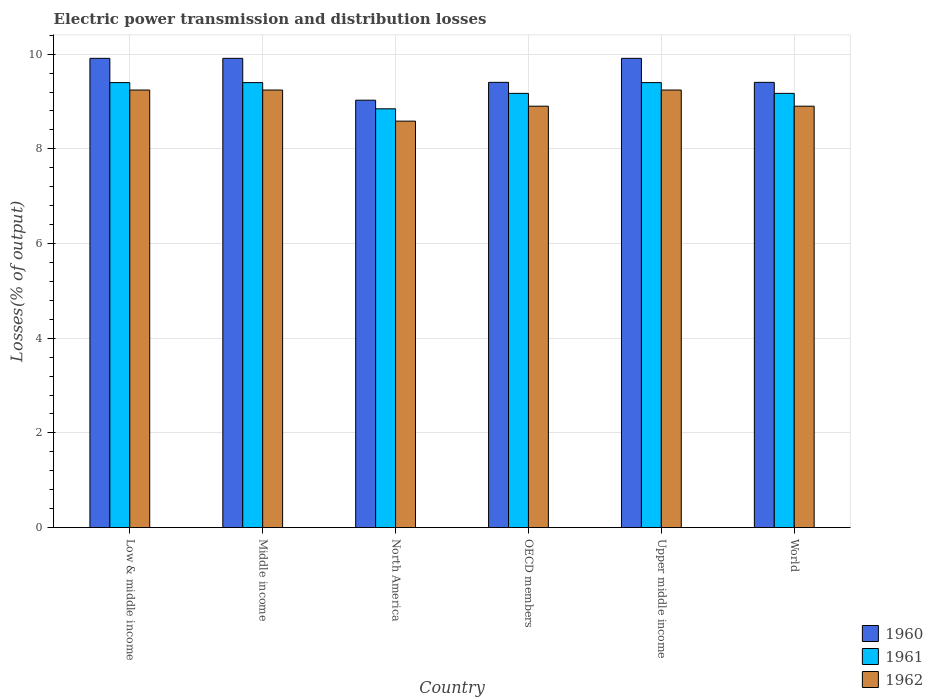How many different coloured bars are there?
Make the answer very short. 3. Are the number of bars per tick equal to the number of legend labels?
Your answer should be very brief. Yes. Are the number of bars on each tick of the X-axis equal?
Your answer should be compact. Yes. How many bars are there on the 6th tick from the right?
Provide a short and direct response. 3. What is the label of the 5th group of bars from the left?
Your answer should be very brief. Upper middle income. In how many cases, is the number of bars for a given country not equal to the number of legend labels?
Your response must be concise. 0. What is the electric power transmission and distribution losses in 1962 in World?
Give a very brief answer. 8.9. Across all countries, what is the maximum electric power transmission and distribution losses in 1961?
Provide a succinct answer. 9.4. Across all countries, what is the minimum electric power transmission and distribution losses in 1962?
Give a very brief answer. 8.59. In which country was the electric power transmission and distribution losses in 1961 maximum?
Offer a very short reply. Low & middle income. In which country was the electric power transmission and distribution losses in 1961 minimum?
Make the answer very short. North America. What is the total electric power transmission and distribution losses in 1961 in the graph?
Ensure brevity in your answer.  55.38. What is the difference between the electric power transmission and distribution losses in 1961 in Low & middle income and that in North America?
Offer a very short reply. 0.55. What is the difference between the electric power transmission and distribution losses in 1962 in Low & middle income and the electric power transmission and distribution losses in 1960 in Middle income?
Keep it short and to the point. -0.67. What is the average electric power transmission and distribution losses in 1960 per country?
Give a very brief answer. 9.59. What is the difference between the electric power transmission and distribution losses of/in 1960 and electric power transmission and distribution losses of/in 1961 in Upper middle income?
Your response must be concise. 0.51. In how many countries, is the electric power transmission and distribution losses in 1961 greater than 8.8 %?
Provide a short and direct response. 6. Is the difference between the electric power transmission and distribution losses in 1960 in Low & middle income and North America greater than the difference between the electric power transmission and distribution losses in 1961 in Low & middle income and North America?
Offer a terse response. Yes. What is the difference between the highest and the lowest electric power transmission and distribution losses in 1961?
Provide a succinct answer. 0.55. In how many countries, is the electric power transmission and distribution losses in 1960 greater than the average electric power transmission and distribution losses in 1960 taken over all countries?
Give a very brief answer. 3. Is the sum of the electric power transmission and distribution losses in 1961 in OECD members and World greater than the maximum electric power transmission and distribution losses in 1960 across all countries?
Keep it short and to the point. Yes. What does the 2nd bar from the right in Upper middle income represents?
Make the answer very short. 1961. Is it the case that in every country, the sum of the electric power transmission and distribution losses in 1961 and electric power transmission and distribution losses in 1962 is greater than the electric power transmission and distribution losses in 1960?
Ensure brevity in your answer.  Yes. How many bars are there?
Provide a short and direct response. 18. How are the legend labels stacked?
Your response must be concise. Vertical. What is the title of the graph?
Offer a very short reply. Electric power transmission and distribution losses. Does "2007" appear as one of the legend labels in the graph?
Give a very brief answer. No. What is the label or title of the X-axis?
Ensure brevity in your answer.  Country. What is the label or title of the Y-axis?
Make the answer very short. Losses(% of output). What is the Losses(% of output) in 1960 in Low & middle income?
Your answer should be very brief. 9.91. What is the Losses(% of output) of 1961 in Low & middle income?
Your answer should be compact. 9.4. What is the Losses(% of output) of 1962 in Low & middle income?
Keep it short and to the point. 9.24. What is the Losses(% of output) in 1960 in Middle income?
Offer a terse response. 9.91. What is the Losses(% of output) of 1961 in Middle income?
Your response must be concise. 9.4. What is the Losses(% of output) of 1962 in Middle income?
Offer a very short reply. 9.24. What is the Losses(% of output) of 1960 in North America?
Provide a short and direct response. 9.03. What is the Losses(% of output) in 1961 in North America?
Give a very brief answer. 8.85. What is the Losses(% of output) in 1962 in North America?
Give a very brief answer. 8.59. What is the Losses(% of output) in 1960 in OECD members?
Provide a short and direct response. 9.4. What is the Losses(% of output) of 1961 in OECD members?
Provide a short and direct response. 9.17. What is the Losses(% of output) in 1962 in OECD members?
Provide a short and direct response. 8.9. What is the Losses(% of output) in 1960 in Upper middle income?
Provide a succinct answer. 9.91. What is the Losses(% of output) of 1961 in Upper middle income?
Offer a very short reply. 9.4. What is the Losses(% of output) of 1962 in Upper middle income?
Your answer should be very brief. 9.24. What is the Losses(% of output) in 1960 in World?
Ensure brevity in your answer.  9.4. What is the Losses(% of output) in 1961 in World?
Keep it short and to the point. 9.17. What is the Losses(% of output) in 1962 in World?
Keep it short and to the point. 8.9. Across all countries, what is the maximum Losses(% of output) of 1960?
Offer a very short reply. 9.91. Across all countries, what is the maximum Losses(% of output) in 1961?
Offer a very short reply. 9.4. Across all countries, what is the maximum Losses(% of output) in 1962?
Offer a very short reply. 9.24. Across all countries, what is the minimum Losses(% of output) in 1960?
Your response must be concise. 9.03. Across all countries, what is the minimum Losses(% of output) of 1961?
Your answer should be very brief. 8.85. Across all countries, what is the minimum Losses(% of output) of 1962?
Give a very brief answer. 8.59. What is the total Losses(% of output) in 1960 in the graph?
Your response must be concise. 57.57. What is the total Losses(% of output) in 1961 in the graph?
Make the answer very short. 55.38. What is the total Losses(% of output) in 1962 in the graph?
Offer a very short reply. 54.11. What is the difference between the Losses(% of output) of 1962 in Low & middle income and that in Middle income?
Give a very brief answer. 0. What is the difference between the Losses(% of output) in 1960 in Low & middle income and that in North America?
Your answer should be very brief. 0.88. What is the difference between the Losses(% of output) in 1961 in Low & middle income and that in North America?
Offer a very short reply. 0.55. What is the difference between the Losses(% of output) in 1962 in Low & middle income and that in North America?
Ensure brevity in your answer.  0.66. What is the difference between the Losses(% of output) of 1960 in Low & middle income and that in OECD members?
Provide a succinct answer. 0.51. What is the difference between the Losses(% of output) in 1961 in Low & middle income and that in OECD members?
Your answer should be compact. 0.23. What is the difference between the Losses(% of output) of 1962 in Low & middle income and that in OECD members?
Offer a terse response. 0.34. What is the difference between the Losses(% of output) in 1960 in Low & middle income and that in Upper middle income?
Make the answer very short. 0. What is the difference between the Losses(% of output) in 1961 in Low & middle income and that in Upper middle income?
Ensure brevity in your answer.  0. What is the difference between the Losses(% of output) of 1960 in Low & middle income and that in World?
Give a very brief answer. 0.51. What is the difference between the Losses(% of output) of 1961 in Low & middle income and that in World?
Give a very brief answer. 0.23. What is the difference between the Losses(% of output) of 1962 in Low & middle income and that in World?
Provide a short and direct response. 0.34. What is the difference between the Losses(% of output) of 1960 in Middle income and that in North America?
Your answer should be compact. 0.88. What is the difference between the Losses(% of output) in 1961 in Middle income and that in North America?
Provide a short and direct response. 0.55. What is the difference between the Losses(% of output) in 1962 in Middle income and that in North America?
Make the answer very short. 0.66. What is the difference between the Losses(% of output) of 1960 in Middle income and that in OECD members?
Your answer should be very brief. 0.51. What is the difference between the Losses(% of output) in 1961 in Middle income and that in OECD members?
Your answer should be compact. 0.23. What is the difference between the Losses(% of output) of 1962 in Middle income and that in OECD members?
Ensure brevity in your answer.  0.34. What is the difference between the Losses(% of output) in 1960 in Middle income and that in Upper middle income?
Offer a terse response. 0. What is the difference between the Losses(% of output) in 1960 in Middle income and that in World?
Your response must be concise. 0.51. What is the difference between the Losses(% of output) in 1961 in Middle income and that in World?
Make the answer very short. 0.23. What is the difference between the Losses(% of output) in 1962 in Middle income and that in World?
Keep it short and to the point. 0.34. What is the difference between the Losses(% of output) in 1960 in North America and that in OECD members?
Ensure brevity in your answer.  -0.38. What is the difference between the Losses(% of output) of 1961 in North America and that in OECD members?
Provide a short and direct response. -0.33. What is the difference between the Losses(% of output) in 1962 in North America and that in OECD members?
Keep it short and to the point. -0.32. What is the difference between the Losses(% of output) in 1960 in North America and that in Upper middle income?
Offer a terse response. -0.88. What is the difference between the Losses(% of output) in 1961 in North America and that in Upper middle income?
Your response must be concise. -0.55. What is the difference between the Losses(% of output) in 1962 in North America and that in Upper middle income?
Offer a very short reply. -0.66. What is the difference between the Losses(% of output) of 1960 in North America and that in World?
Provide a short and direct response. -0.38. What is the difference between the Losses(% of output) in 1961 in North America and that in World?
Offer a terse response. -0.33. What is the difference between the Losses(% of output) of 1962 in North America and that in World?
Ensure brevity in your answer.  -0.32. What is the difference between the Losses(% of output) of 1960 in OECD members and that in Upper middle income?
Ensure brevity in your answer.  -0.51. What is the difference between the Losses(% of output) in 1961 in OECD members and that in Upper middle income?
Make the answer very short. -0.23. What is the difference between the Losses(% of output) in 1962 in OECD members and that in Upper middle income?
Ensure brevity in your answer.  -0.34. What is the difference between the Losses(% of output) in 1961 in OECD members and that in World?
Your answer should be compact. 0. What is the difference between the Losses(% of output) of 1962 in OECD members and that in World?
Provide a succinct answer. 0. What is the difference between the Losses(% of output) of 1960 in Upper middle income and that in World?
Make the answer very short. 0.51. What is the difference between the Losses(% of output) of 1961 in Upper middle income and that in World?
Ensure brevity in your answer.  0.23. What is the difference between the Losses(% of output) of 1962 in Upper middle income and that in World?
Your response must be concise. 0.34. What is the difference between the Losses(% of output) of 1960 in Low & middle income and the Losses(% of output) of 1961 in Middle income?
Make the answer very short. 0.51. What is the difference between the Losses(% of output) in 1960 in Low & middle income and the Losses(% of output) in 1962 in Middle income?
Offer a very short reply. 0.67. What is the difference between the Losses(% of output) of 1961 in Low & middle income and the Losses(% of output) of 1962 in Middle income?
Make the answer very short. 0.16. What is the difference between the Losses(% of output) of 1960 in Low & middle income and the Losses(% of output) of 1961 in North America?
Provide a succinct answer. 1.07. What is the difference between the Losses(% of output) in 1960 in Low & middle income and the Losses(% of output) in 1962 in North America?
Provide a short and direct response. 1.33. What is the difference between the Losses(% of output) in 1961 in Low & middle income and the Losses(% of output) in 1962 in North America?
Provide a short and direct response. 0.81. What is the difference between the Losses(% of output) of 1960 in Low & middle income and the Losses(% of output) of 1961 in OECD members?
Make the answer very short. 0.74. What is the difference between the Losses(% of output) in 1960 in Low & middle income and the Losses(% of output) in 1962 in OECD members?
Ensure brevity in your answer.  1.01. What is the difference between the Losses(% of output) of 1961 in Low & middle income and the Losses(% of output) of 1962 in OECD members?
Ensure brevity in your answer.  0.5. What is the difference between the Losses(% of output) of 1960 in Low & middle income and the Losses(% of output) of 1961 in Upper middle income?
Your response must be concise. 0.51. What is the difference between the Losses(% of output) of 1960 in Low & middle income and the Losses(% of output) of 1962 in Upper middle income?
Provide a short and direct response. 0.67. What is the difference between the Losses(% of output) in 1961 in Low & middle income and the Losses(% of output) in 1962 in Upper middle income?
Provide a short and direct response. 0.16. What is the difference between the Losses(% of output) of 1960 in Low & middle income and the Losses(% of output) of 1961 in World?
Your response must be concise. 0.74. What is the difference between the Losses(% of output) of 1960 in Low & middle income and the Losses(% of output) of 1962 in World?
Your answer should be compact. 1.01. What is the difference between the Losses(% of output) in 1961 in Low & middle income and the Losses(% of output) in 1962 in World?
Provide a short and direct response. 0.5. What is the difference between the Losses(% of output) of 1960 in Middle income and the Losses(% of output) of 1961 in North America?
Keep it short and to the point. 1.07. What is the difference between the Losses(% of output) in 1960 in Middle income and the Losses(% of output) in 1962 in North America?
Provide a succinct answer. 1.33. What is the difference between the Losses(% of output) in 1961 in Middle income and the Losses(% of output) in 1962 in North America?
Ensure brevity in your answer.  0.81. What is the difference between the Losses(% of output) of 1960 in Middle income and the Losses(% of output) of 1961 in OECD members?
Your answer should be very brief. 0.74. What is the difference between the Losses(% of output) of 1960 in Middle income and the Losses(% of output) of 1962 in OECD members?
Keep it short and to the point. 1.01. What is the difference between the Losses(% of output) of 1961 in Middle income and the Losses(% of output) of 1962 in OECD members?
Provide a succinct answer. 0.5. What is the difference between the Losses(% of output) of 1960 in Middle income and the Losses(% of output) of 1961 in Upper middle income?
Provide a short and direct response. 0.51. What is the difference between the Losses(% of output) in 1960 in Middle income and the Losses(% of output) in 1962 in Upper middle income?
Your answer should be very brief. 0.67. What is the difference between the Losses(% of output) in 1961 in Middle income and the Losses(% of output) in 1962 in Upper middle income?
Offer a very short reply. 0.16. What is the difference between the Losses(% of output) of 1960 in Middle income and the Losses(% of output) of 1961 in World?
Keep it short and to the point. 0.74. What is the difference between the Losses(% of output) of 1960 in Middle income and the Losses(% of output) of 1962 in World?
Your answer should be very brief. 1.01. What is the difference between the Losses(% of output) in 1961 in Middle income and the Losses(% of output) in 1962 in World?
Give a very brief answer. 0.5. What is the difference between the Losses(% of output) in 1960 in North America and the Losses(% of output) in 1961 in OECD members?
Give a very brief answer. -0.14. What is the difference between the Losses(% of output) in 1960 in North America and the Losses(% of output) in 1962 in OECD members?
Your answer should be very brief. 0.13. What is the difference between the Losses(% of output) in 1961 in North America and the Losses(% of output) in 1962 in OECD members?
Offer a terse response. -0.06. What is the difference between the Losses(% of output) of 1960 in North America and the Losses(% of output) of 1961 in Upper middle income?
Ensure brevity in your answer.  -0.37. What is the difference between the Losses(% of output) in 1960 in North America and the Losses(% of output) in 1962 in Upper middle income?
Provide a short and direct response. -0.21. What is the difference between the Losses(% of output) of 1961 in North America and the Losses(% of output) of 1962 in Upper middle income?
Your answer should be compact. -0.4. What is the difference between the Losses(% of output) in 1960 in North America and the Losses(% of output) in 1961 in World?
Keep it short and to the point. -0.14. What is the difference between the Losses(% of output) of 1960 in North America and the Losses(% of output) of 1962 in World?
Offer a terse response. 0.13. What is the difference between the Losses(% of output) in 1961 in North America and the Losses(% of output) in 1962 in World?
Provide a succinct answer. -0.06. What is the difference between the Losses(% of output) of 1960 in OECD members and the Losses(% of output) of 1961 in Upper middle income?
Provide a succinct answer. 0.01. What is the difference between the Losses(% of output) in 1960 in OECD members and the Losses(% of output) in 1962 in Upper middle income?
Your answer should be very brief. 0.16. What is the difference between the Losses(% of output) in 1961 in OECD members and the Losses(% of output) in 1962 in Upper middle income?
Keep it short and to the point. -0.07. What is the difference between the Losses(% of output) of 1960 in OECD members and the Losses(% of output) of 1961 in World?
Provide a succinct answer. 0.23. What is the difference between the Losses(% of output) of 1960 in OECD members and the Losses(% of output) of 1962 in World?
Your answer should be very brief. 0.5. What is the difference between the Losses(% of output) of 1961 in OECD members and the Losses(% of output) of 1962 in World?
Make the answer very short. 0.27. What is the difference between the Losses(% of output) of 1960 in Upper middle income and the Losses(% of output) of 1961 in World?
Provide a short and direct response. 0.74. What is the difference between the Losses(% of output) of 1960 in Upper middle income and the Losses(% of output) of 1962 in World?
Your answer should be compact. 1.01. What is the difference between the Losses(% of output) of 1961 in Upper middle income and the Losses(% of output) of 1962 in World?
Ensure brevity in your answer.  0.5. What is the average Losses(% of output) of 1960 per country?
Provide a short and direct response. 9.59. What is the average Losses(% of output) in 1961 per country?
Offer a terse response. 9.23. What is the average Losses(% of output) in 1962 per country?
Offer a very short reply. 9.02. What is the difference between the Losses(% of output) in 1960 and Losses(% of output) in 1961 in Low & middle income?
Provide a succinct answer. 0.51. What is the difference between the Losses(% of output) of 1960 and Losses(% of output) of 1962 in Low & middle income?
Your response must be concise. 0.67. What is the difference between the Losses(% of output) in 1961 and Losses(% of output) in 1962 in Low & middle income?
Provide a short and direct response. 0.16. What is the difference between the Losses(% of output) in 1960 and Losses(% of output) in 1961 in Middle income?
Make the answer very short. 0.51. What is the difference between the Losses(% of output) in 1960 and Losses(% of output) in 1962 in Middle income?
Make the answer very short. 0.67. What is the difference between the Losses(% of output) of 1961 and Losses(% of output) of 1962 in Middle income?
Offer a terse response. 0.16. What is the difference between the Losses(% of output) of 1960 and Losses(% of output) of 1961 in North America?
Your response must be concise. 0.18. What is the difference between the Losses(% of output) of 1960 and Losses(% of output) of 1962 in North America?
Your response must be concise. 0.44. What is the difference between the Losses(% of output) of 1961 and Losses(% of output) of 1962 in North America?
Make the answer very short. 0.26. What is the difference between the Losses(% of output) in 1960 and Losses(% of output) in 1961 in OECD members?
Make the answer very short. 0.23. What is the difference between the Losses(% of output) of 1960 and Losses(% of output) of 1962 in OECD members?
Your response must be concise. 0.5. What is the difference between the Losses(% of output) in 1961 and Losses(% of output) in 1962 in OECD members?
Make the answer very short. 0.27. What is the difference between the Losses(% of output) in 1960 and Losses(% of output) in 1961 in Upper middle income?
Give a very brief answer. 0.51. What is the difference between the Losses(% of output) of 1960 and Losses(% of output) of 1962 in Upper middle income?
Provide a succinct answer. 0.67. What is the difference between the Losses(% of output) of 1961 and Losses(% of output) of 1962 in Upper middle income?
Provide a short and direct response. 0.16. What is the difference between the Losses(% of output) in 1960 and Losses(% of output) in 1961 in World?
Make the answer very short. 0.23. What is the difference between the Losses(% of output) of 1960 and Losses(% of output) of 1962 in World?
Your response must be concise. 0.5. What is the difference between the Losses(% of output) of 1961 and Losses(% of output) of 1962 in World?
Provide a succinct answer. 0.27. What is the ratio of the Losses(% of output) of 1960 in Low & middle income to that in Middle income?
Offer a very short reply. 1. What is the ratio of the Losses(% of output) of 1961 in Low & middle income to that in Middle income?
Provide a short and direct response. 1. What is the ratio of the Losses(% of output) in 1960 in Low & middle income to that in North America?
Ensure brevity in your answer.  1.1. What is the ratio of the Losses(% of output) of 1961 in Low & middle income to that in North America?
Your answer should be compact. 1.06. What is the ratio of the Losses(% of output) in 1962 in Low & middle income to that in North America?
Ensure brevity in your answer.  1.08. What is the ratio of the Losses(% of output) in 1960 in Low & middle income to that in OECD members?
Ensure brevity in your answer.  1.05. What is the ratio of the Losses(% of output) in 1961 in Low & middle income to that in OECD members?
Offer a very short reply. 1.02. What is the ratio of the Losses(% of output) of 1962 in Low & middle income to that in OECD members?
Your answer should be very brief. 1.04. What is the ratio of the Losses(% of output) in 1960 in Low & middle income to that in World?
Provide a short and direct response. 1.05. What is the ratio of the Losses(% of output) in 1961 in Low & middle income to that in World?
Keep it short and to the point. 1.02. What is the ratio of the Losses(% of output) in 1962 in Low & middle income to that in World?
Keep it short and to the point. 1.04. What is the ratio of the Losses(% of output) in 1960 in Middle income to that in North America?
Your response must be concise. 1.1. What is the ratio of the Losses(% of output) of 1961 in Middle income to that in North America?
Your response must be concise. 1.06. What is the ratio of the Losses(% of output) of 1962 in Middle income to that in North America?
Offer a very short reply. 1.08. What is the ratio of the Losses(% of output) in 1960 in Middle income to that in OECD members?
Offer a very short reply. 1.05. What is the ratio of the Losses(% of output) of 1961 in Middle income to that in OECD members?
Your answer should be very brief. 1.02. What is the ratio of the Losses(% of output) in 1962 in Middle income to that in OECD members?
Your answer should be very brief. 1.04. What is the ratio of the Losses(% of output) in 1960 in Middle income to that in Upper middle income?
Keep it short and to the point. 1. What is the ratio of the Losses(% of output) of 1961 in Middle income to that in Upper middle income?
Offer a terse response. 1. What is the ratio of the Losses(% of output) of 1962 in Middle income to that in Upper middle income?
Give a very brief answer. 1. What is the ratio of the Losses(% of output) in 1960 in Middle income to that in World?
Your answer should be very brief. 1.05. What is the ratio of the Losses(% of output) of 1961 in Middle income to that in World?
Your answer should be very brief. 1.02. What is the ratio of the Losses(% of output) of 1962 in Middle income to that in World?
Make the answer very short. 1.04. What is the ratio of the Losses(% of output) in 1960 in North America to that in OECD members?
Ensure brevity in your answer.  0.96. What is the ratio of the Losses(% of output) in 1961 in North America to that in OECD members?
Ensure brevity in your answer.  0.96. What is the ratio of the Losses(% of output) in 1962 in North America to that in OECD members?
Offer a terse response. 0.96. What is the ratio of the Losses(% of output) in 1960 in North America to that in Upper middle income?
Offer a very short reply. 0.91. What is the ratio of the Losses(% of output) in 1961 in North America to that in Upper middle income?
Provide a short and direct response. 0.94. What is the ratio of the Losses(% of output) of 1962 in North America to that in Upper middle income?
Keep it short and to the point. 0.93. What is the ratio of the Losses(% of output) in 1960 in North America to that in World?
Your answer should be very brief. 0.96. What is the ratio of the Losses(% of output) in 1961 in North America to that in World?
Give a very brief answer. 0.96. What is the ratio of the Losses(% of output) in 1962 in North America to that in World?
Make the answer very short. 0.96. What is the ratio of the Losses(% of output) of 1960 in OECD members to that in Upper middle income?
Offer a very short reply. 0.95. What is the ratio of the Losses(% of output) of 1961 in OECD members to that in Upper middle income?
Give a very brief answer. 0.98. What is the ratio of the Losses(% of output) of 1962 in OECD members to that in Upper middle income?
Ensure brevity in your answer.  0.96. What is the ratio of the Losses(% of output) in 1960 in Upper middle income to that in World?
Make the answer very short. 1.05. What is the ratio of the Losses(% of output) in 1961 in Upper middle income to that in World?
Ensure brevity in your answer.  1.02. What is the ratio of the Losses(% of output) in 1962 in Upper middle income to that in World?
Keep it short and to the point. 1.04. What is the difference between the highest and the second highest Losses(% of output) of 1961?
Keep it short and to the point. 0. What is the difference between the highest and the lowest Losses(% of output) of 1960?
Provide a short and direct response. 0.88. What is the difference between the highest and the lowest Losses(% of output) of 1961?
Your answer should be compact. 0.55. What is the difference between the highest and the lowest Losses(% of output) in 1962?
Offer a very short reply. 0.66. 